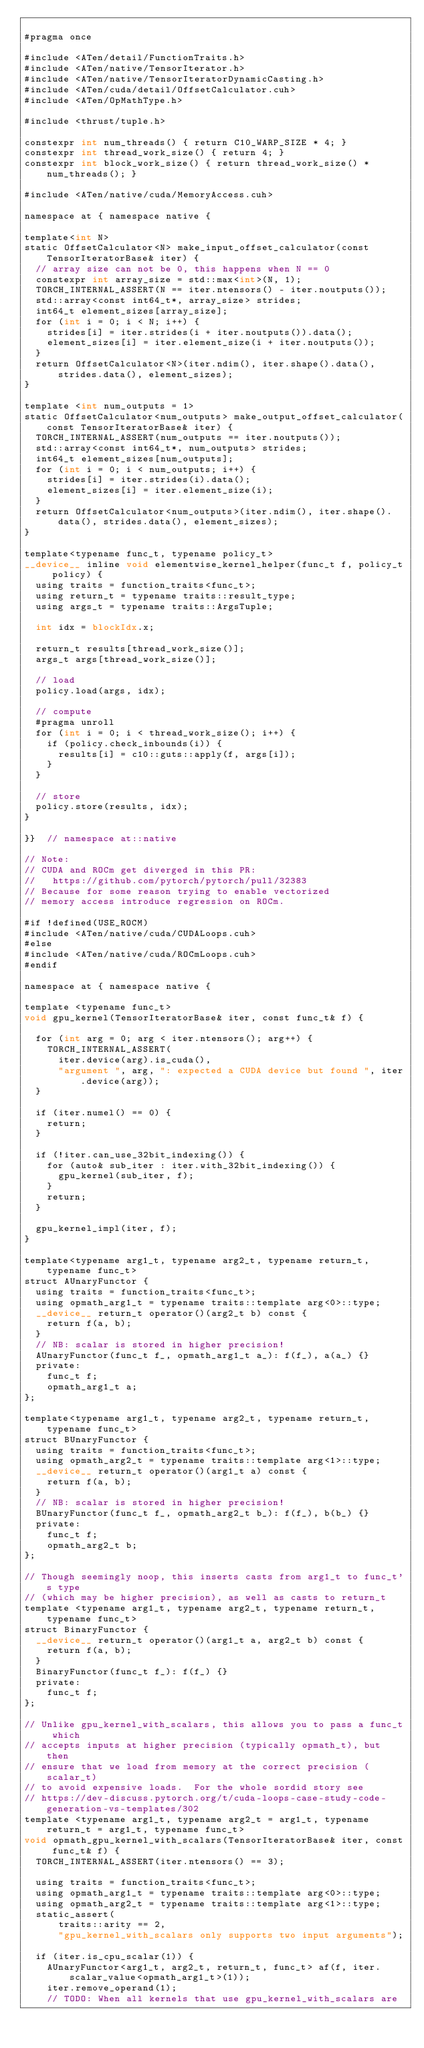Convert code to text. <code><loc_0><loc_0><loc_500><loc_500><_Cuda_>
#pragma once

#include <ATen/detail/FunctionTraits.h>
#include <ATen/native/TensorIterator.h>
#include <ATen/native/TensorIteratorDynamicCasting.h>
#include <ATen/cuda/detail/OffsetCalculator.cuh>
#include <ATen/OpMathType.h>

#include <thrust/tuple.h>

constexpr int num_threads() { return C10_WARP_SIZE * 4; }
constexpr int thread_work_size() { return 4; }
constexpr int block_work_size() { return thread_work_size() * num_threads(); }

#include <ATen/native/cuda/MemoryAccess.cuh>

namespace at { namespace native {

template<int N>
static OffsetCalculator<N> make_input_offset_calculator(const TensorIteratorBase& iter) {
  // array size can not be 0, this happens when N == 0
  constexpr int array_size = std::max<int>(N, 1);
  TORCH_INTERNAL_ASSERT(N == iter.ntensors() - iter.noutputs());
  std::array<const int64_t*, array_size> strides;
  int64_t element_sizes[array_size];
  for (int i = 0; i < N; i++) {
    strides[i] = iter.strides(i + iter.noutputs()).data();
    element_sizes[i] = iter.element_size(i + iter.noutputs());
  }
  return OffsetCalculator<N>(iter.ndim(), iter.shape().data(), strides.data(), element_sizes);
}

template <int num_outputs = 1>
static OffsetCalculator<num_outputs> make_output_offset_calculator(const TensorIteratorBase& iter) {
  TORCH_INTERNAL_ASSERT(num_outputs == iter.noutputs());
  std::array<const int64_t*, num_outputs> strides;
  int64_t element_sizes[num_outputs];
  for (int i = 0; i < num_outputs; i++) {
    strides[i] = iter.strides(i).data();
    element_sizes[i] = iter.element_size(i);
  }
  return OffsetCalculator<num_outputs>(iter.ndim(), iter.shape().data(), strides.data(), element_sizes);
}

template<typename func_t, typename policy_t>
__device__ inline void elementwise_kernel_helper(func_t f, policy_t policy) {
  using traits = function_traits<func_t>;
  using return_t = typename traits::result_type;
  using args_t = typename traits::ArgsTuple;

  int idx = blockIdx.x;

  return_t results[thread_work_size()];
  args_t args[thread_work_size()];

  // load
  policy.load(args, idx);

  // compute
  #pragma unroll
  for (int i = 0; i < thread_work_size(); i++) {
    if (policy.check_inbounds(i)) {
      results[i] = c10::guts::apply(f, args[i]);
    }
  }

  // store
  policy.store(results, idx);
}

}}  // namespace at::native

// Note:
// CUDA and ROCm get diverged in this PR:
//   https://github.com/pytorch/pytorch/pull/32383
// Because for some reason trying to enable vectorized
// memory access introduce regression on ROCm.

#if !defined(USE_ROCM)
#include <ATen/native/cuda/CUDALoops.cuh>
#else
#include <ATen/native/cuda/ROCmLoops.cuh>
#endif

namespace at { namespace native {

template <typename func_t>
void gpu_kernel(TensorIteratorBase& iter, const func_t& f) {

  for (int arg = 0; arg < iter.ntensors(); arg++) {
    TORCH_INTERNAL_ASSERT(
      iter.device(arg).is_cuda(),
      "argument ", arg, ": expected a CUDA device but found ", iter.device(arg));
  }

  if (iter.numel() == 0) {
    return;
  }

  if (!iter.can_use_32bit_indexing()) {
    for (auto& sub_iter : iter.with_32bit_indexing()) {
      gpu_kernel(sub_iter, f);
    }
    return;
  }

  gpu_kernel_impl(iter, f);
}

template<typename arg1_t, typename arg2_t, typename return_t, typename func_t>
struct AUnaryFunctor {
  using traits = function_traits<func_t>;
  using opmath_arg1_t = typename traits::template arg<0>::type;
  __device__ return_t operator()(arg2_t b) const {
    return f(a, b);
  }
  // NB: scalar is stored in higher precision!
  AUnaryFunctor(func_t f_, opmath_arg1_t a_): f(f_), a(a_) {}
  private:
    func_t f;
    opmath_arg1_t a;
};

template<typename arg1_t, typename arg2_t, typename return_t, typename func_t>
struct BUnaryFunctor {
  using traits = function_traits<func_t>;
  using opmath_arg2_t = typename traits::template arg<1>::type;
  __device__ return_t operator()(arg1_t a) const {
    return f(a, b);
  }
  // NB: scalar is stored in higher precision!
  BUnaryFunctor(func_t f_, opmath_arg2_t b_): f(f_), b(b_) {}
  private:
    func_t f;
    opmath_arg2_t b;
};

// Though seemingly noop, this inserts casts from arg1_t to func_t's type
// (which may be higher precision), as well as casts to return_t
template <typename arg1_t, typename arg2_t, typename return_t, typename func_t>
struct BinaryFunctor {
  __device__ return_t operator()(arg1_t a, arg2_t b) const {
    return f(a, b);
  }
  BinaryFunctor(func_t f_): f(f_) {}
  private:
    func_t f;
};

// Unlike gpu_kernel_with_scalars, this allows you to pass a func_t which
// accepts inputs at higher precision (typically opmath_t), but then
// ensure that we load from memory at the correct precision (scalar_t)
// to avoid expensive loads.  For the whole sordid story see
// https://dev-discuss.pytorch.org/t/cuda-loops-case-study-code-generation-vs-templates/302
template <typename arg1_t, typename arg2_t = arg1_t, typename return_t = arg1_t, typename func_t>
void opmath_gpu_kernel_with_scalars(TensorIteratorBase& iter, const func_t& f) {
  TORCH_INTERNAL_ASSERT(iter.ntensors() == 3);

  using traits = function_traits<func_t>;
  using opmath_arg1_t = typename traits::template arg<0>::type;
  using opmath_arg2_t = typename traits::template arg<1>::type;
  static_assert(
      traits::arity == 2,
      "gpu_kernel_with_scalars only supports two input arguments");

  if (iter.is_cpu_scalar(1)) {
    AUnaryFunctor<arg1_t, arg2_t, return_t, func_t> af(f, iter.scalar_value<opmath_arg1_t>(1));
    iter.remove_operand(1);
    // TODO: When all kernels that use gpu_kernel_with_scalars are</code> 